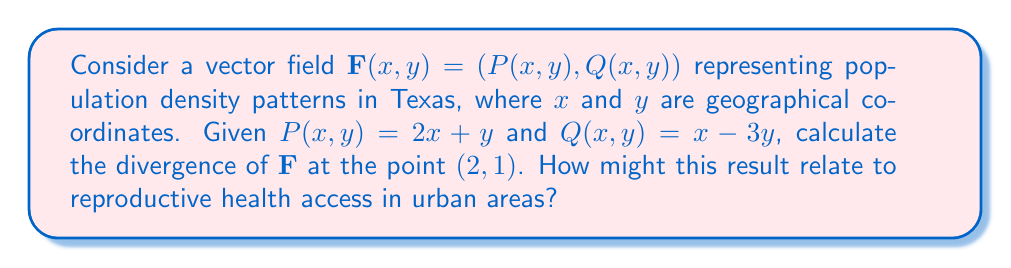Show me your answer to this math problem. To solve this problem, we'll follow these steps:

1) The divergence of a vector field $\mathbf{F}(x,y) = (P(x,y), Q(x,y))$ is given by:

   $$\text{div}\mathbf{F} = \nabla \cdot \mathbf{F} = \frac{\partial P}{\partial x} + \frac{\partial Q}{\partial y}$$

2) We need to find $\frac{\partial P}{\partial x}$ and $\frac{\partial Q}{\partial y}$:

   $\frac{\partial P}{\partial x} = \frac{\partial}{\partial x}(2x + y) = 2$
   
   $\frac{\partial Q}{\partial y} = \frac{\partial}{\partial y}(x - 3y) = -3$

3) Now we can calculate the divergence:

   $$\text{div}\mathbf{F} = \frac{\partial P}{\partial x} + \frac{\partial Q}{\partial y} = 2 + (-3) = -1$$

4) The divergence is constant for this vector field, so it's the same at all points, including (2,1).

5) A negative divergence indicates that the vector field is converging at this point. In terms of population density, this could represent a net inflow of people into urban areas.

6) Relating to reproductive health: Urban areas with increasing population density may face challenges in providing adequate reproductive health services. This could lead to increased demand for reproductive health clinics and resources in cities.
Answer: $-1$ 